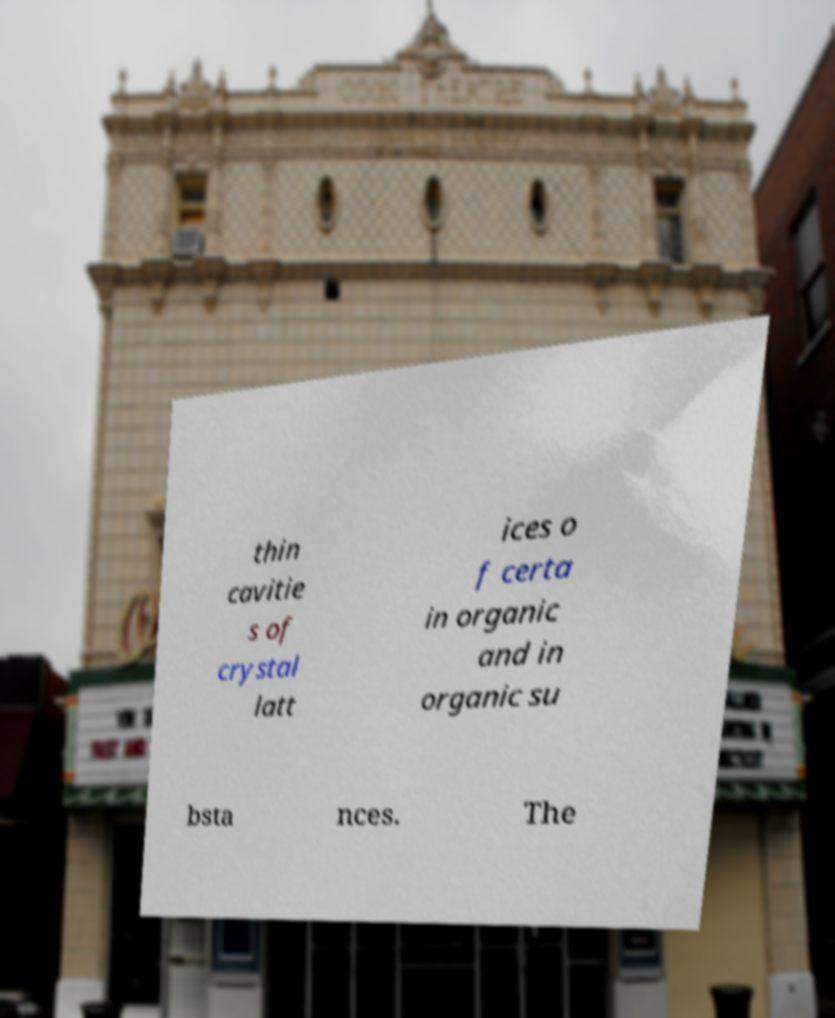Please identify and transcribe the text found in this image. thin cavitie s of crystal latt ices o f certa in organic and in organic su bsta nces. The 